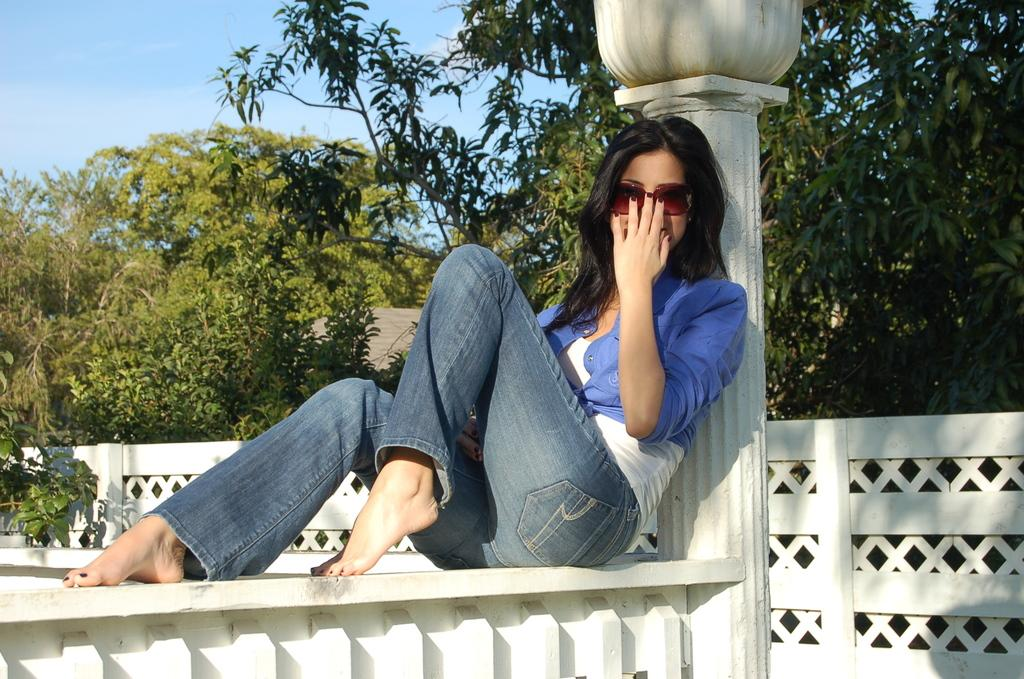What is the woman in the image doing? The woman is sitting on a wall in the image. What can be seen in the background of the image? There is a pillar and trees in the background of the image. What is visible at the top of the image? The sky is visible at the top of the image. What type of potato is being used as a prop in the image? There is no potato present in the image. Can you tell me how many receipts are visible in the image? There are no receipts visible in the image. 